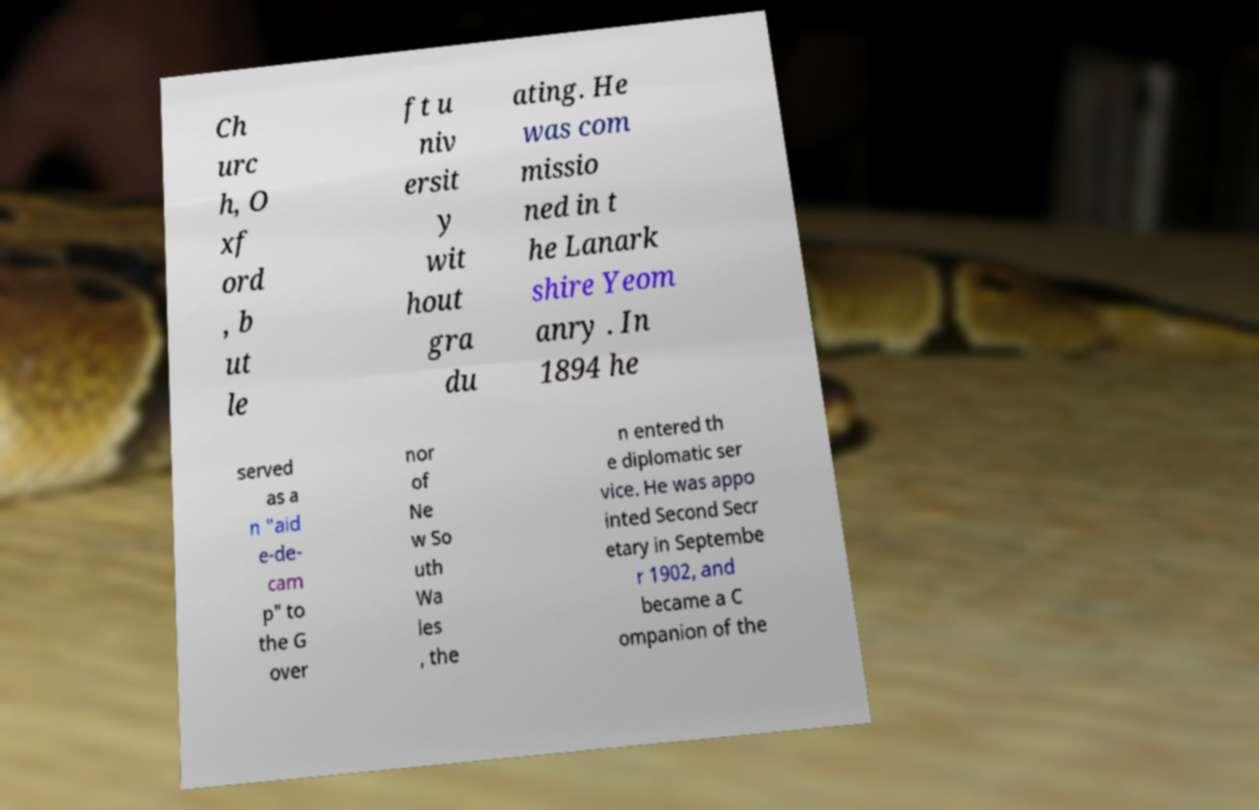I need the written content from this picture converted into text. Can you do that? Ch urc h, O xf ord , b ut le ft u niv ersit y wit hout gra du ating. He was com missio ned in t he Lanark shire Yeom anry . In 1894 he served as a n "aid e-de- cam p" to the G over nor of Ne w So uth Wa les , the n entered th e diplomatic ser vice. He was appo inted Second Secr etary in Septembe r 1902, and became a C ompanion of the 